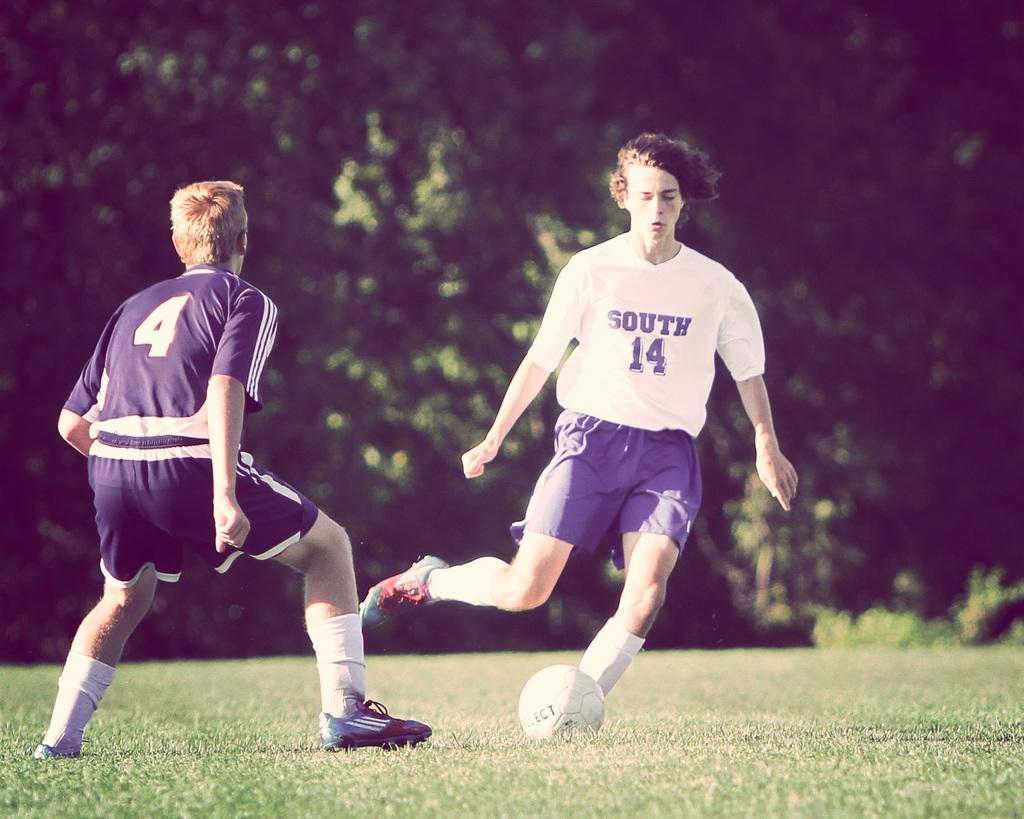How many people are playing football in the image? There are two people in the image playing football. Where is the football game taking place? The football game is taking place in a garden. What is the main object being used in the game? There is a football visible in the image. What can be seen in the background of the image? There are trees visible in the background of the image. What religious book is being read by one of the players during the football game? There is no religious book present in the image; the two people are focused on playing football. Is there a jail visible in the background of the image? There is no jail present in the image; the background features trees. 